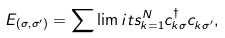<formula> <loc_0><loc_0><loc_500><loc_500>E _ { ( \sigma , \sigma ^ { \prime } ) } = \sum \lim i t s _ { k = 1 } ^ { N } c ^ { \dagger } _ { k \sigma } c ^ { \, } _ { k \sigma ^ { \prime } } ,</formula> 